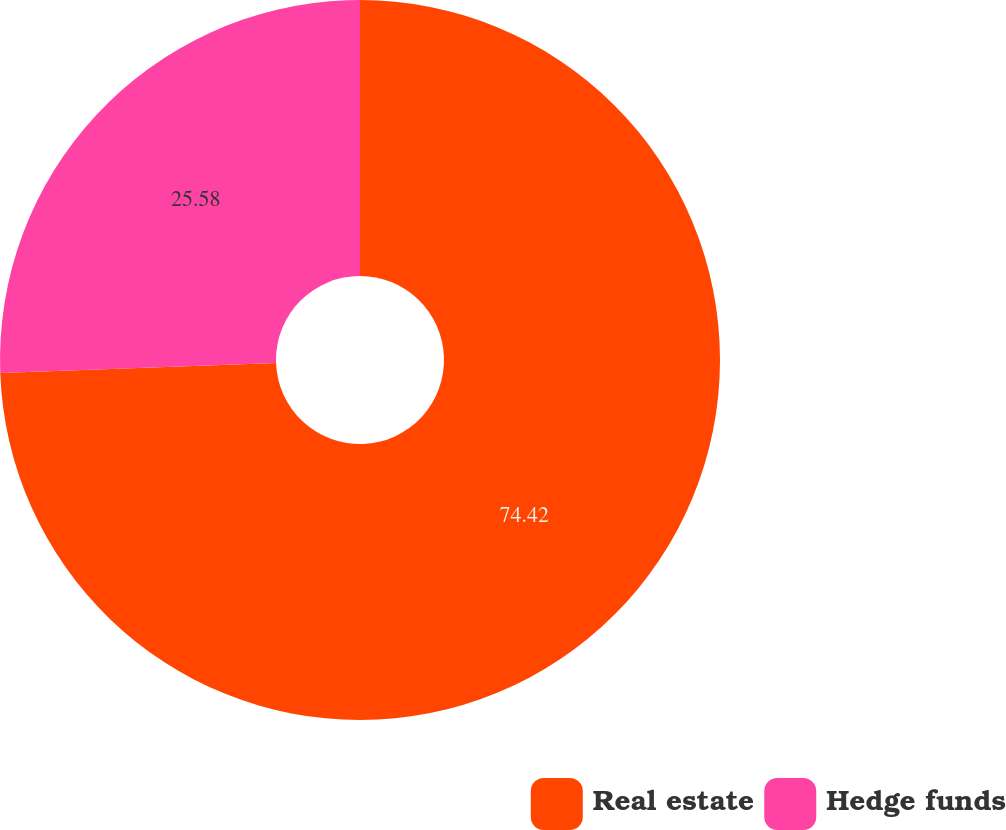Convert chart. <chart><loc_0><loc_0><loc_500><loc_500><pie_chart><fcel>Real estate<fcel>Hedge funds<nl><fcel>74.42%<fcel>25.58%<nl></chart> 